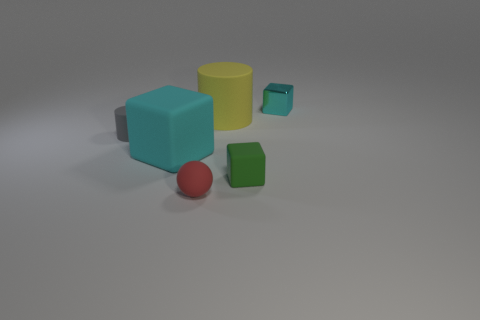Subtract all big matte blocks. How many blocks are left? 2 Subtract all purple balls. How many cyan blocks are left? 2 Add 3 small spheres. How many objects exist? 9 Subtract 1 cylinders. How many cylinders are left? 1 Subtract all cylinders. How many objects are left? 4 Subtract all large blue rubber cylinders. Subtract all tiny red matte balls. How many objects are left? 5 Add 6 yellow rubber things. How many yellow rubber things are left? 7 Add 2 green things. How many green things exist? 3 Subtract 0 gray spheres. How many objects are left? 6 Subtract all purple cubes. Subtract all green cylinders. How many cubes are left? 3 